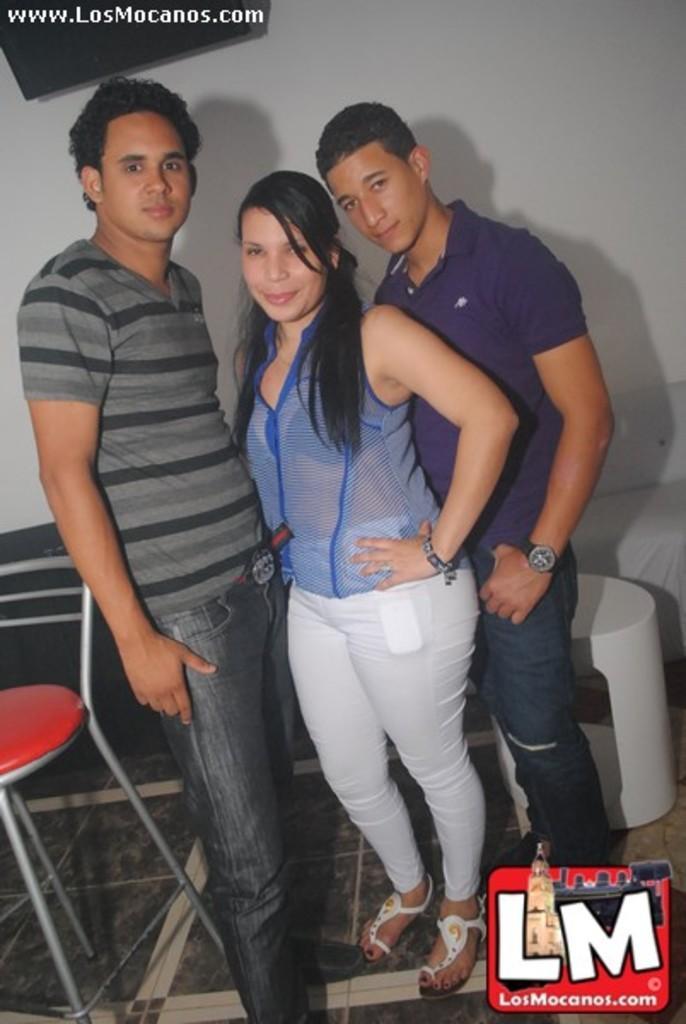Please provide a concise description of this image. In this image we can see three people standing on the floor, there is a chair beside the man and there is a table and a couch behind the man and there is a wall with black color object in the background. 